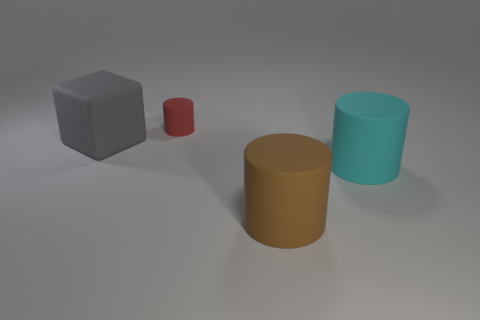Add 1 tiny rubber cylinders. How many objects exist? 5 Subtract all large cylinders. How many cylinders are left? 1 Subtract all blocks. How many objects are left? 3 Add 2 tiny brown metallic objects. How many tiny brown metallic objects exist? 2 Subtract all red cylinders. How many cylinders are left? 2 Subtract 0 yellow cylinders. How many objects are left? 4 Subtract 3 cylinders. How many cylinders are left? 0 Subtract all blue blocks. Subtract all brown spheres. How many blocks are left? 1 Subtract all gray blocks. How many cyan cylinders are left? 1 Subtract all shiny things. Subtract all big cyan things. How many objects are left? 3 